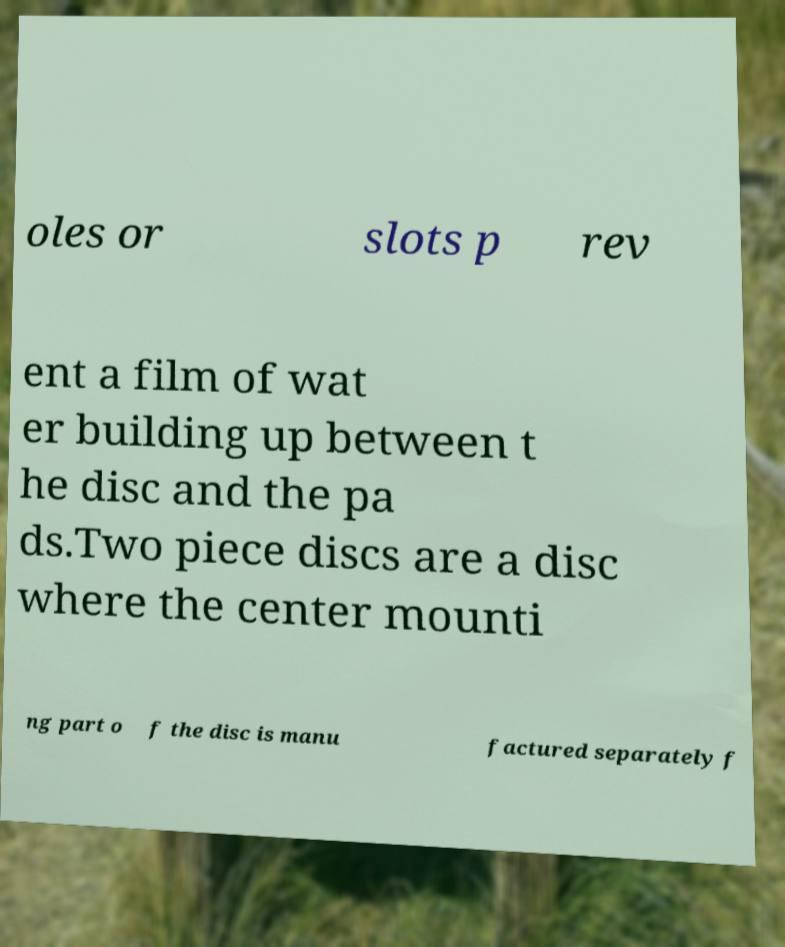Please identify and transcribe the text found in this image. oles or slots p rev ent a film of wat er building up between t he disc and the pa ds.Two piece discs are a disc where the center mounti ng part o f the disc is manu factured separately f 